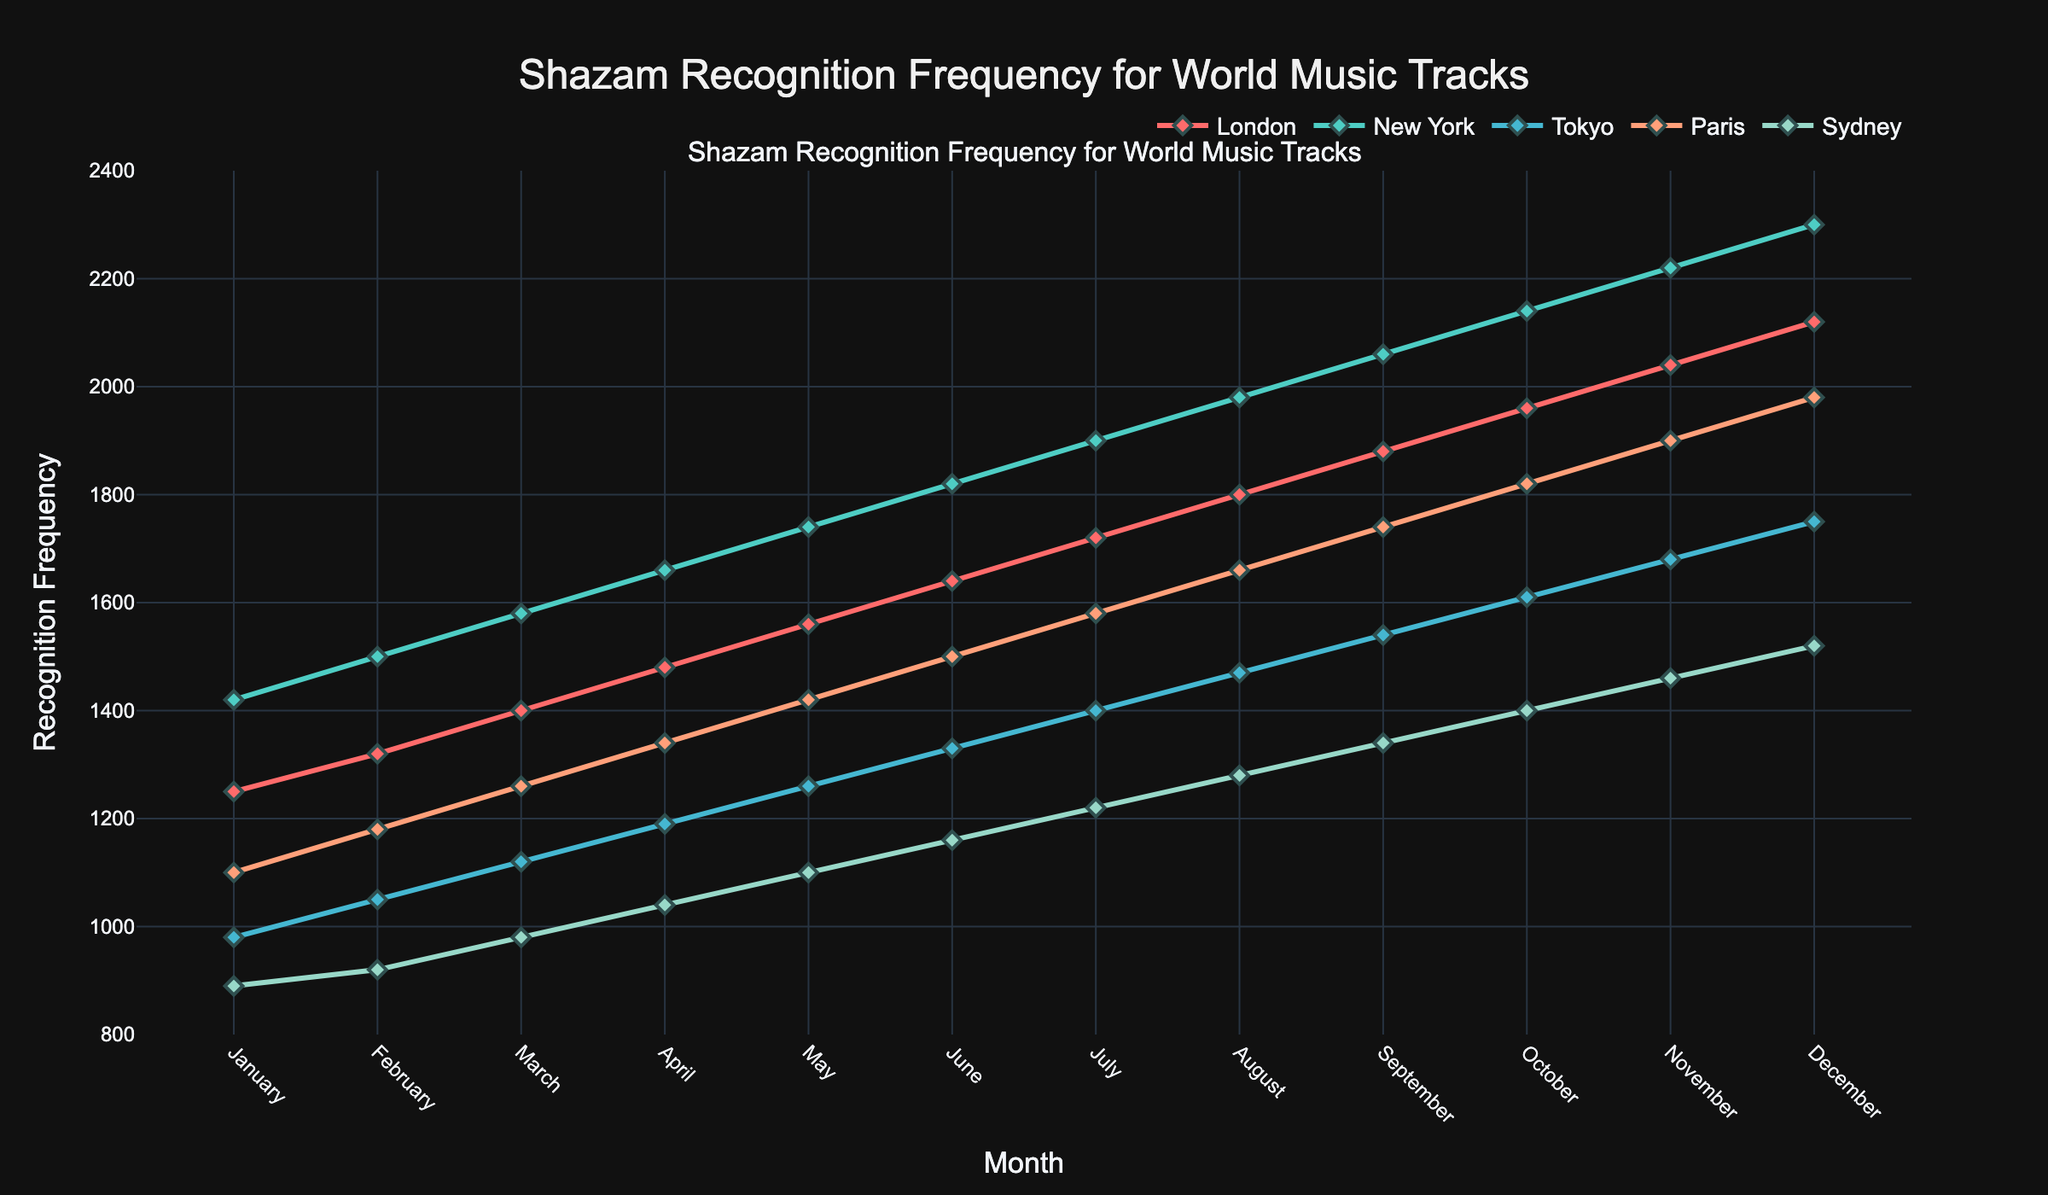What is the recognition frequency for New York in June? To find the recognition frequency for New York in June, look at the point in the graph corresponding to June on the x-axis and New York (the line color associated with New York).
Answer: 1820 Which city had the highest recognition frequency in December? Check the data points for December on the x-axis. Look at the line with the highest peak in December. The highest line represents the city with the highest recognition frequency.
Answer: New York Which city showed the most significant increase in recognition frequency from January to December? Calculate the difference between the December and January recognition frequencies for each city. The city with the largest difference experienced the most significant increase. For example, for London, it is 2120 - 1250 = 870, etc.
Answer: New York How does the recognition frequency in Sydney in February compare to Tokyo in the same month? Refer to the points representing February on the x-axis and compare the y-values for Sydney and Tokyo. Sydney is at 920 and Tokyo is at 1050, so Tokyo's frequency is higher.
Answer: Tokyo is higher What is the average recognition frequency in Paris for the first half of the year (January to June)? Sum the recognition frequencies in Paris from January to June and divide by the number of months (6). E.g., (1100 + 1180 + 1260 + 1340 + 1420 + 1500) / 6 = 7800 / 6 = 1300
Answer: 1300 Which city has the steepest line increment from November to December? Look at the slopes of the lines from November to December. The line with the steepest upward movement (greatest change in y-value) indicates the city. Calculate for each city if needed: e.g., for New York, it is 2300 - 2220 = 80.
Answer: Paris In which month did London surpass a recognition frequency of 1500? Identify the months along the x-axis and find where London's line crosses the 1500 mark on the y-axis. London is above 1500 starting from May.
Answer: May What is the total recognition frequency for Sydney from January to December? Sum the recognition frequencies for Sydney across all months from January to December: e.g., 890 + 920 + 980 + 1040 + 1100 + 1160 + 1220 + 1280 + 1340 + 1400 + 1460 + 1520.
Answer: 15310 In which month did Tokyo have the lowest recognition frequency, and what was it? Identify the month where Tokyo's line is at its lowest point. The frequency value at that point is the lowest recognition frequency. Tokyo is lowest in January at 980.
Answer: January, 980 Compare the color of the lines representing Sydney and Paris. Identify the color of the lines by their corresponding city names in the legend. Sydney is represented by a greenish color, and Paris is light orange.
Answer: Sydney is light green, Paris is light orange 